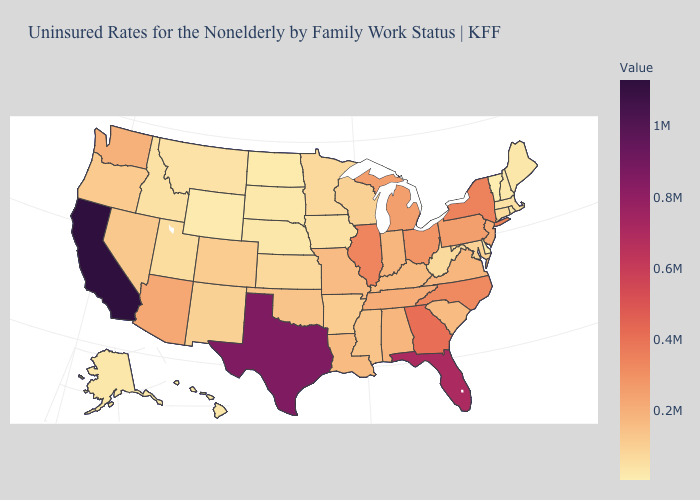Does Texas have a higher value than Illinois?
Be succinct. Yes. Does Illinois have the highest value in the MidWest?
Concise answer only. Yes. Does the map have missing data?
Keep it brief. No. Which states hav the highest value in the MidWest?
Keep it brief. Illinois. Among the states that border Kansas , does Nebraska have the lowest value?
Give a very brief answer. Yes. Does Connecticut have the highest value in the USA?
Keep it brief. No. Which states have the lowest value in the USA?
Give a very brief answer. Vermont. 